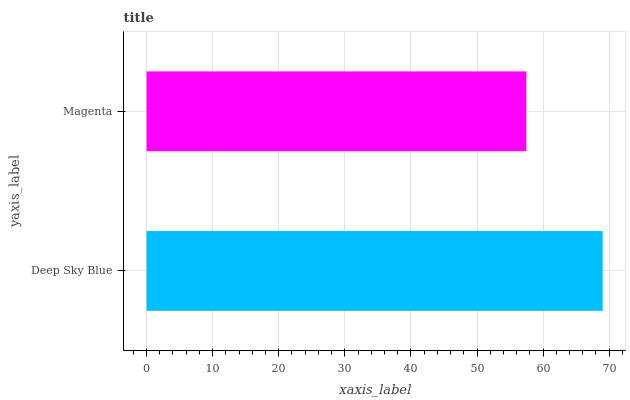Is Magenta the minimum?
Answer yes or no. Yes. Is Deep Sky Blue the maximum?
Answer yes or no. Yes. Is Magenta the maximum?
Answer yes or no. No. Is Deep Sky Blue greater than Magenta?
Answer yes or no. Yes. Is Magenta less than Deep Sky Blue?
Answer yes or no. Yes. Is Magenta greater than Deep Sky Blue?
Answer yes or no. No. Is Deep Sky Blue less than Magenta?
Answer yes or no. No. Is Deep Sky Blue the high median?
Answer yes or no. Yes. Is Magenta the low median?
Answer yes or no. Yes. Is Magenta the high median?
Answer yes or no. No. Is Deep Sky Blue the low median?
Answer yes or no. No. 